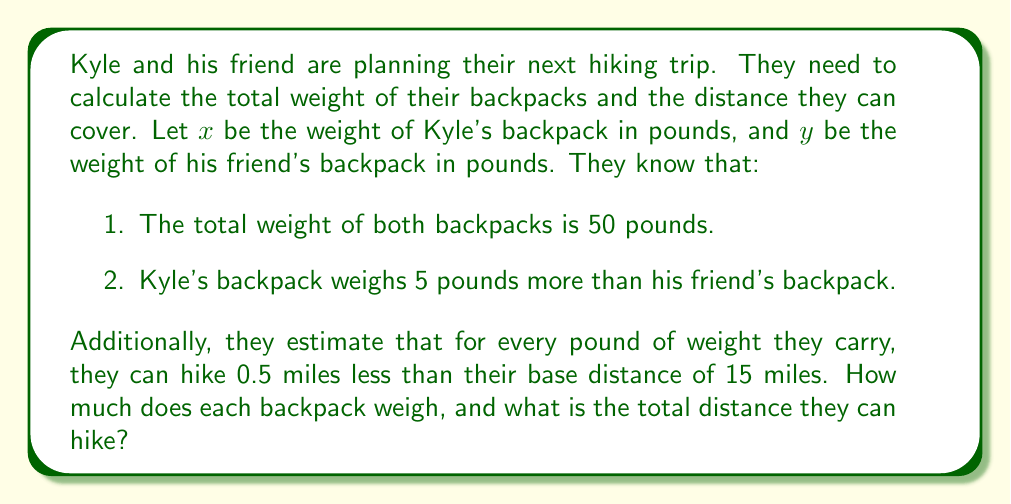Provide a solution to this math problem. Let's solve this problem step by step:

1. Set up the system of equations:
   $$x + y = 50$$ (total weight)
   $$x = y + 5$$ (Kyle's backpack is 5 pounds heavier)

2. Substitute the second equation into the first:
   $$(y + 5) + y = 50$$
   $$2y + 5 = 50$$

3. Solve for y:
   $$2y = 45$$
   $$y = 22.5$$

4. Find x by substituting y back into the second equation:
   $$x = 22.5 + 5 = 27.5$$

5. Calculate the total distance they can hike:
   Base distance: 15 miles
   Weight penalty: $0.5 \times (x + y) = 0.5 \times 50 = 25$ miles
   Total distance: $15 - 25 = -10$ miles

   However, since a negative distance doesn't make sense, we'll assume they can't hike at all with this much weight.
Answer: Kyle's backpack: 27.5 lbs, Friend's backpack: 22.5 lbs, Total hiking distance: 0 miles 